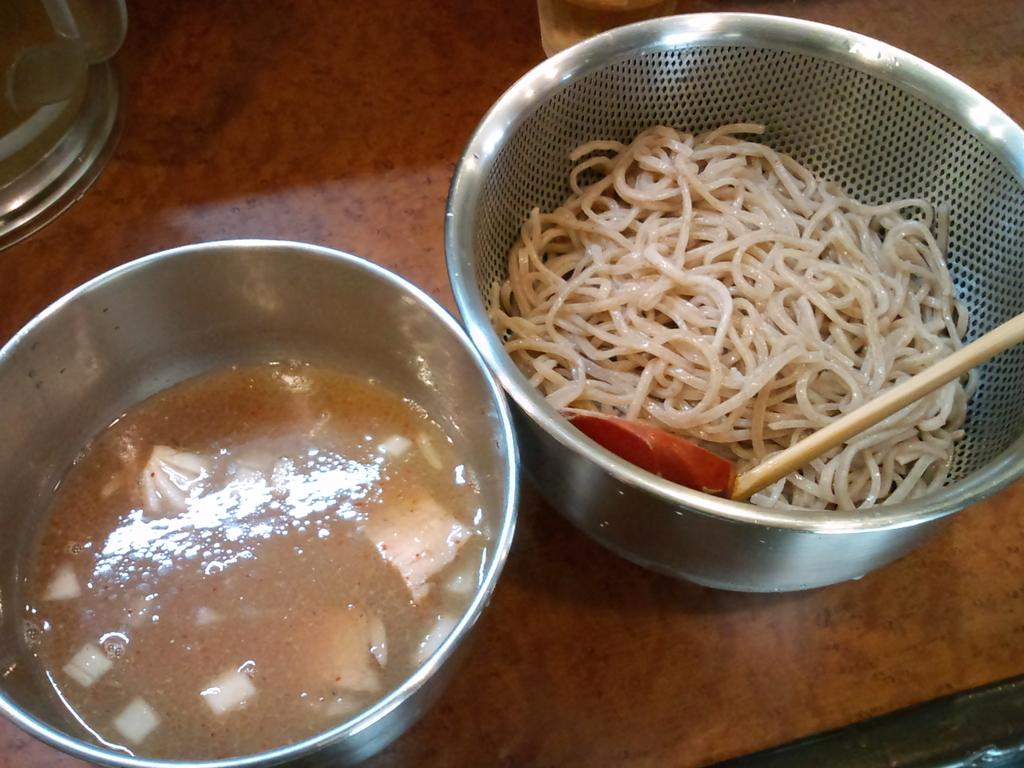What can be seen in the vessels in the image? There are food items in the vessels in the image. What object is visible that could be used for stirring or pointing? There is a stick visible in the image. What type of container is present for holding a beverage? There is a glass in the image. What is located on the counter in the image? There is a jar on the counter in the image. How much payment is required for the items in the image? There is no indication of payment or any transaction in the image. --- Facts: 1. There is a person sitting on a chair in the image. 2. The person is holding a book. 3. There is a table next to the chair. 4. There is a lamp on the table. 5. The background of the image is a wall. Absurd Topics: parrot, ocean, bicycle Conversation: What is the person in the image doing? The person is sitting on a chair in the image. What object is the person holding? The person is holding a book. What is located next to the chair? There is a table next to the chair. What object is on the table? There is a lamp on the table. What can be seen in the background of the image? The background of the image is a wall. Reasoning: Let's think step by step in order to produce the conversation. We start by identifying the main subject in the image, which is the person sitting on a chair. Then, we expand the conversation to include other objects that are also visible, such as the book, the table, the lamp, and the wall in the background. Each question is designed to elicit a specific detail about the image that is known from the provided facts. Absurd Question/Answer: Can you see a parrot flying over the ocean in the image? There is no parrot or ocean present in the image; it features a person sitting on a chair with a book, a table, a lamp, and a wall in the background. 